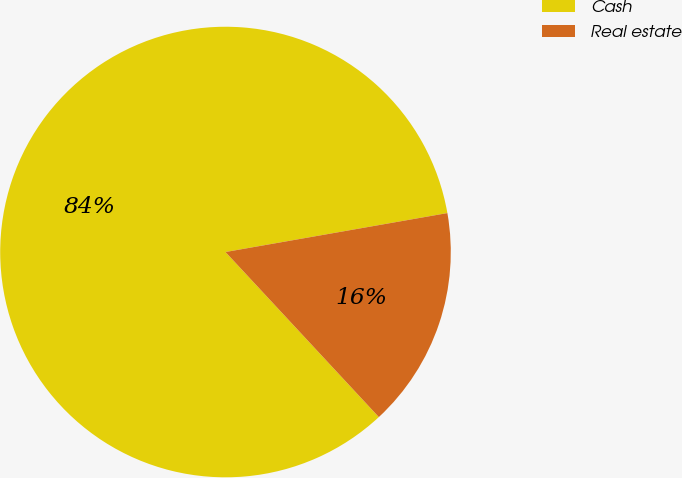<chart> <loc_0><loc_0><loc_500><loc_500><pie_chart><fcel>Cash<fcel>Real estate<nl><fcel>84.15%<fcel>15.85%<nl></chart> 